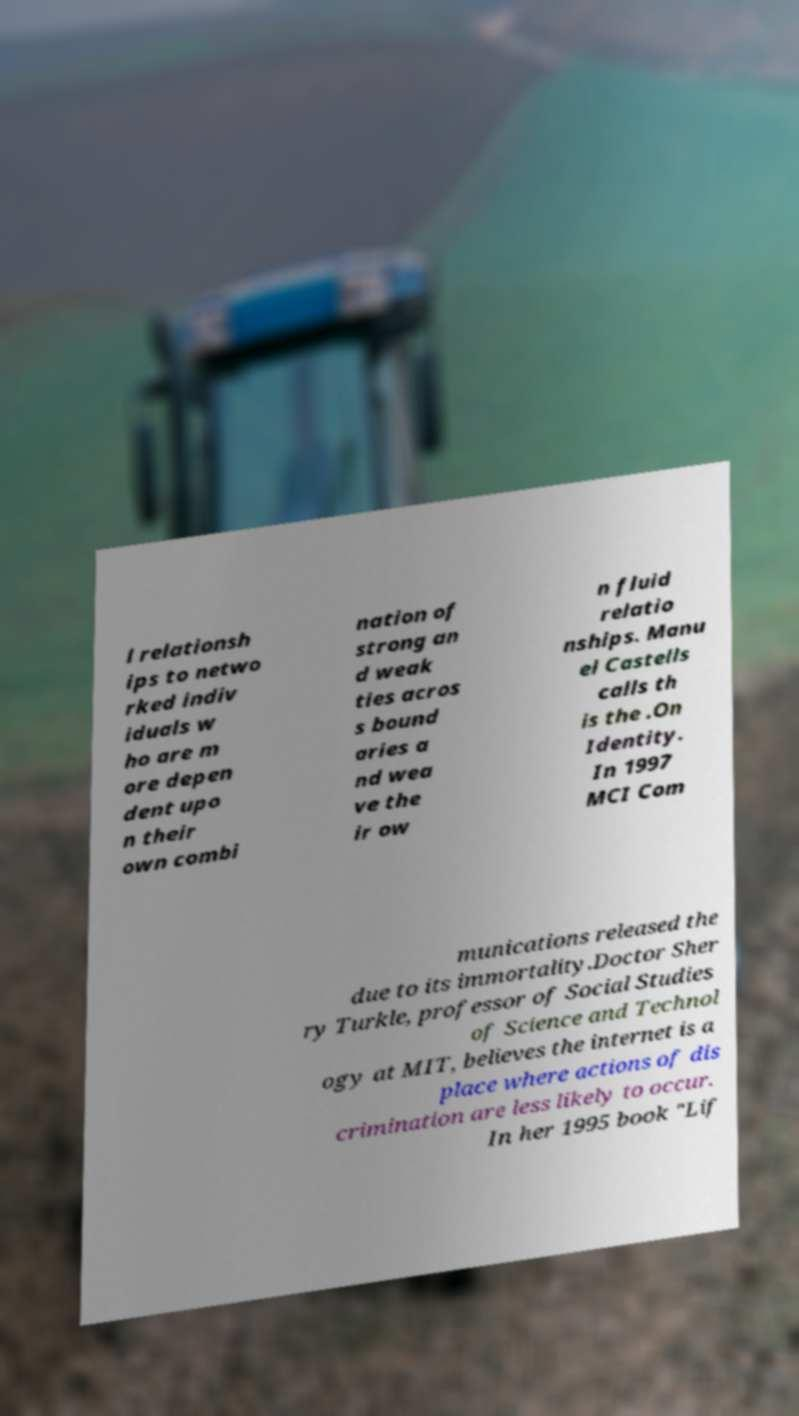Please read and relay the text visible in this image. What does it say? l relationsh ips to netwo rked indiv iduals w ho are m ore depen dent upo n their own combi nation of strong an d weak ties acros s bound aries a nd wea ve the ir ow n fluid relatio nships. Manu el Castells calls th is the .On Identity. In 1997 MCI Com munications released the due to its immortality.Doctor Sher ry Turkle, professor of Social Studies of Science and Technol ogy at MIT, believes the internet is a place where actions of dis crimination are less likely to occur. In her 1995 book "Lif 